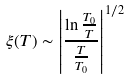<formula> <loc_0><loc_0><loc_500><loc_500>\xi ( T ) \sim \left | \frac { \ln \frac { T _ { 0 } } { T } } { \frac { T } { T _ { 0 } } } \right | ^ { 1 / 2 }</formula> 